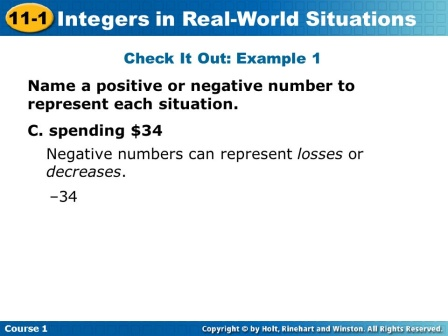What could be the significance of the red color used for the integer? The red color used for the integer '-34' signifies importance and caution, drawing attention to the fact that this value represents a loss or a negative outcome. Red is often used in educational materials to highlight key points or alert students to something significant. In this case, it effectively emphasizes that spending $34 is a negative action in terms of financial representation. Can you describe a realistic scenario in a classroom where this slide might be used? Sure! Here’s a short realistic scenario:

Ms. Johnson, a middle school math teacher, begins her lesson on integers with a slide titled '11-1 Integers in Real-World Situations.' She presents the example 'C. spending $34' to her students, encouraging them to think about how money spent can be represented as a negative number. She explains, 'If you spend money, your account balance decreases, which we can show using a negative number.' The answer '-34' in red catches the students' attention, making the concept clearer and more memorable. Can you imagine a more complex scenario involving multiple steps where students would apply the concepts from this slide? Absolutely, here’s a detailed scenario:

In Mrs. Carter’s 8th-grade math class, students are learning about integers and their real-world applications. She presents them with a multi-part activity titled 'Running a Small Business.' The scenario involves several financial transactions over a week.

1. **Day 1:** The students start with a budget of $500. They spend $100 on supplies (write '-100').
2. **Day 2:** They earn $200 from sales (write '+200').
3. **Day 3:** An unexpected expense of $50 arises (write '-50') as they need to repair their equipment.
4. **Day 4:** They receive a grant of $150 for small businesses (write '+150') and also spend $75 on marketing (write '-75').
5. **Day 5:** Sales increase, earning them an additional $300 (write '+300'), but they also spend $120 on employee wages (write '-120').

Mrs. Carter breaks down each transaction, guiding the students to calculate their running balance after each step, visually representing positive and negative integers as additions and subtractions in their ledger. This exercise not only reinforces the concept of integers but also teaches practical financial literacy skills. 